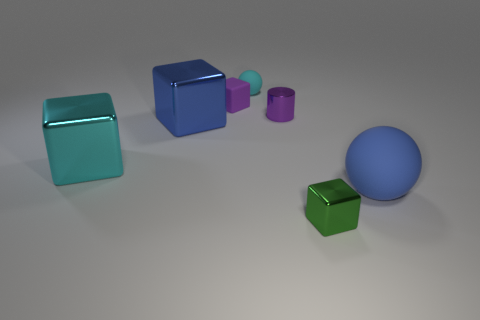Add 2 large cyan metal blocks. How many objects exist? 9 Subtract all blocks. How many objects are left? 3 Add 2 cyan metal objects. How many cyan metal objects exist? 3 Subtract 1 blue cubes. How many objects are left? 6 Subtract all big cyan things. Subtract all small purple balls. How many objects are left? 6 Add 2 big rubber objects. How many big rubber objects are left? 3 